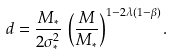Convert formula to latex. <formula><loc_0><loc_0><loc_500><loc_500>d = \frac { M _ { * } } { 2 \sigma _ { * } ^ { 2 } } \, \left ( \frac { M } { M _ { * } } \right ) ^ { 1 - 2 \lambda ( 1 - \beta ) } .</formula> 